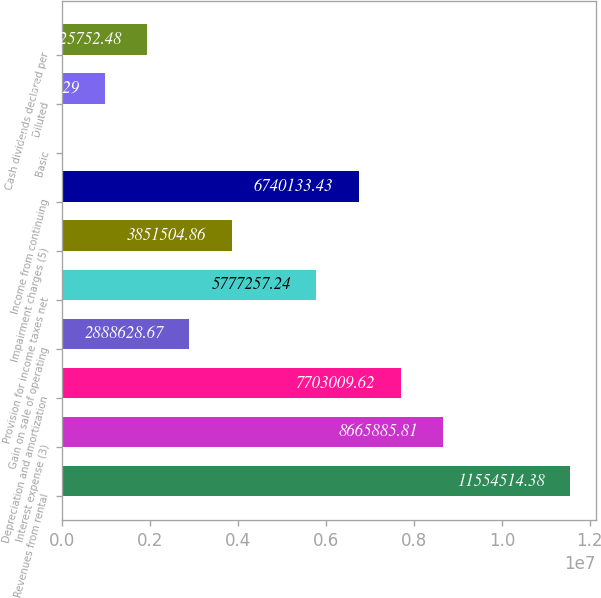<chart> <loc_0><loc_0><loc_500><loc_500><bar_chart><fcel>Revenues from rental<fcel>Interest expense (3)<fcel>Depreciation and amortization<fcel>Gain on sale of operating<fcel>Provision for income taxes net<fcel>Impairment charges (5)<fcel>Income from continuing<fcel>Basic<fcel>Diluted<fcel>Cash dividends declared per<nl><fcel>1.15545e+07<fcel>8.66589e+06<fcel>7.70301e+06<fcel>2.88863e+06<fcel>5.77726e+06<fcel>3.8515e+06<fcel>6.74013e+06<fcel>0.1<fcel>962876<fcel>1.92575e+06<nl></chart> 